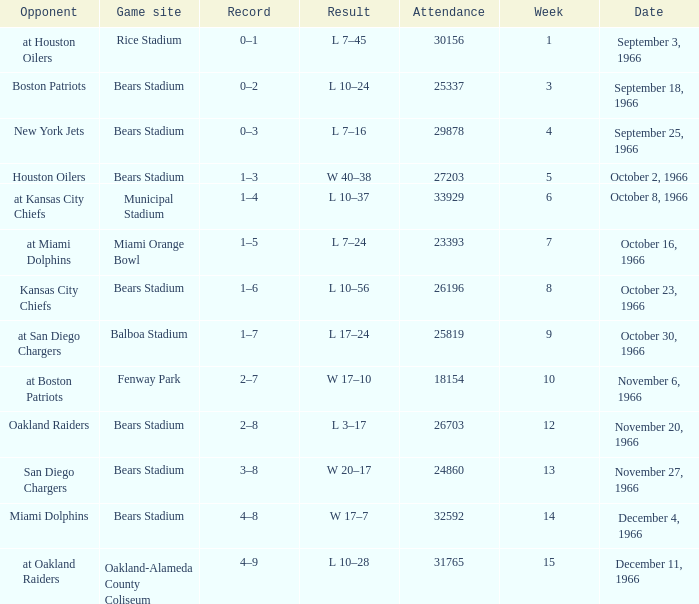On October 16, 1966, what was the game site? Miami Orange Bowl. 